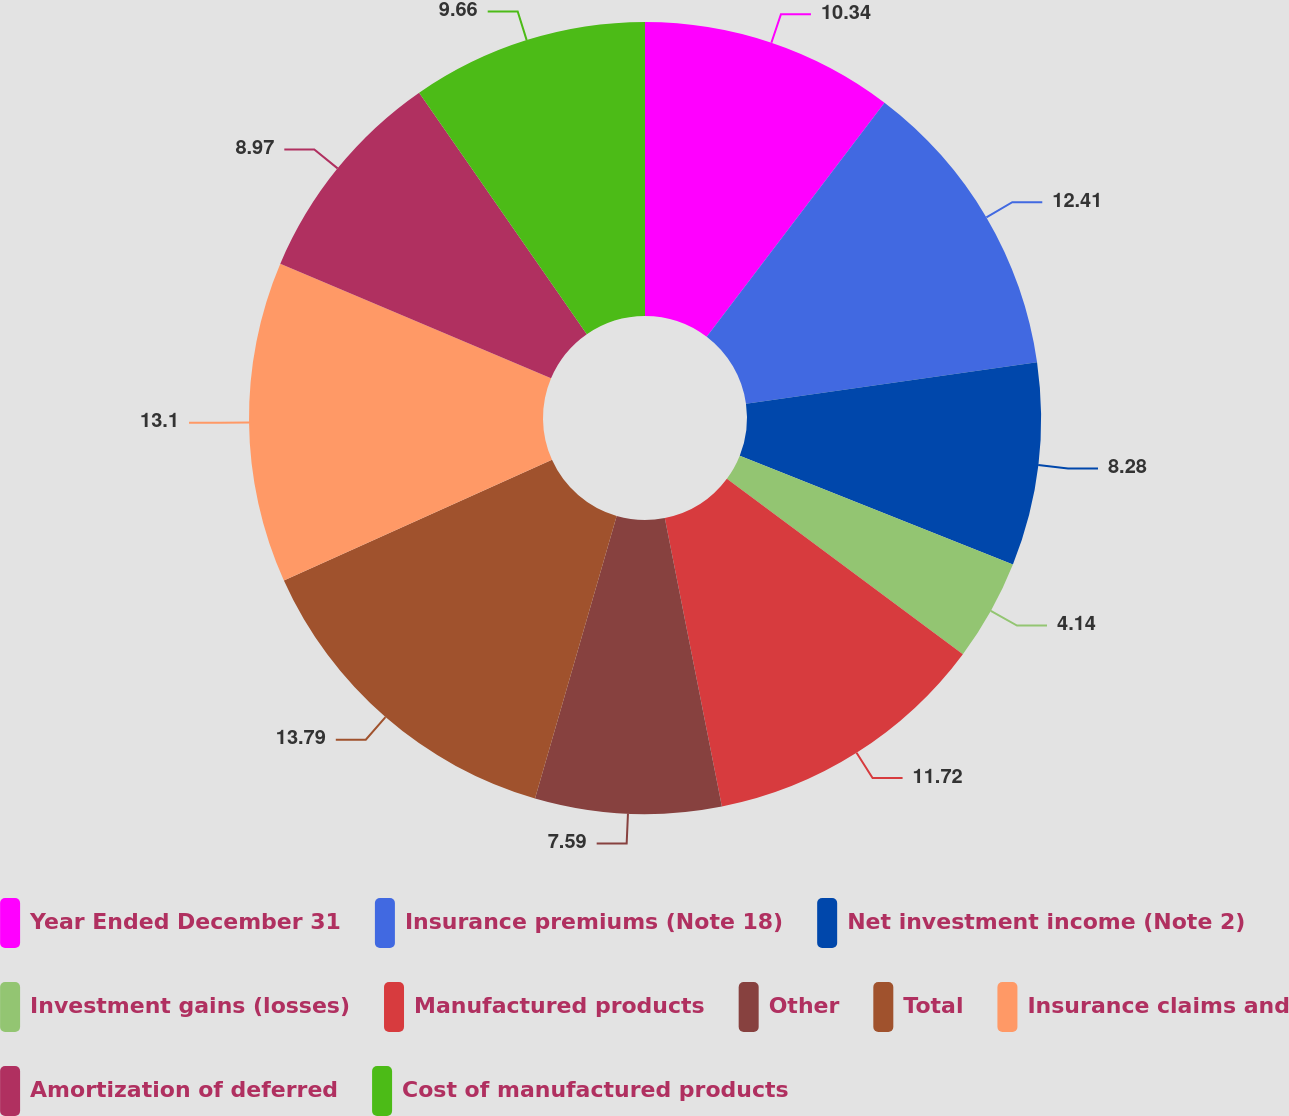Convert chart to OTSL. <chart><loc_0><loc_0><loc_500><loc_500><pie_chart><fcel>Year Ended December 31<fcel>Insurance premiums (Note 18)<fcel>Net investment income (Note 2)<fcel>Investment gains (losses)<fcel>Manufactured products<fcel>Other<fcel>Total<fcel>Insurance claims and<fcel>Amortization of deferred<fcel>Cost of manufactured products<nl><fcel>10.34%<fcel>12.41%<fcel>8.28%<fcel>4.14%<fcel>11.72%<fcel>7.59%<fcel>13.79%<fcel>13.1%<fcel>8.97%<fcel>9.66%<nl></chart> 